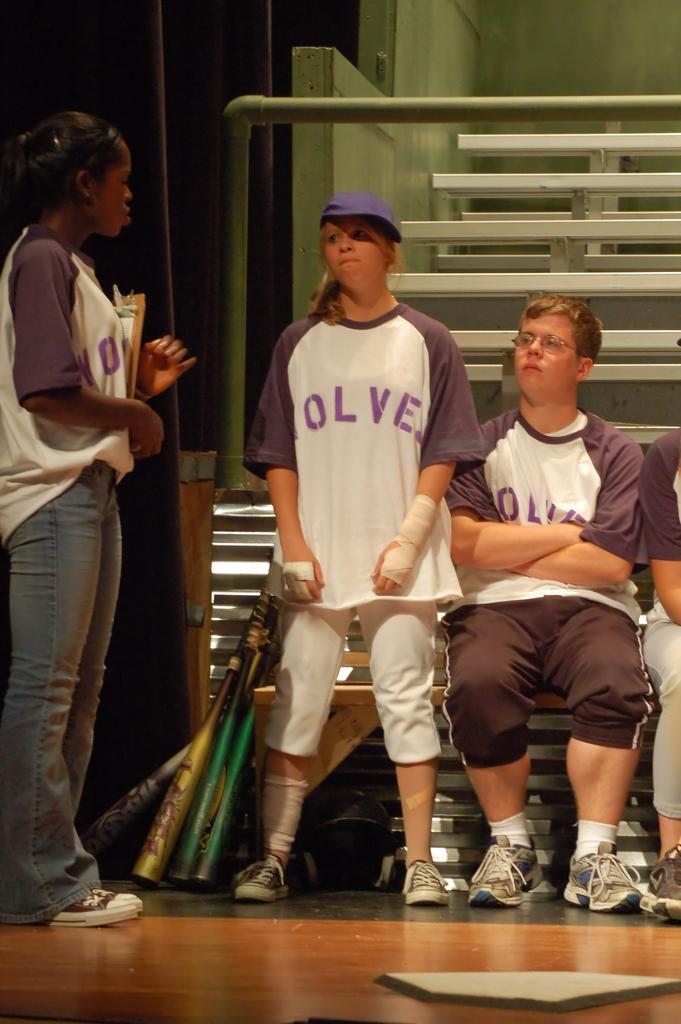<image>
Summarize the visual content of the image. A female baseball player with the letters OLVE visible on her shirt. 